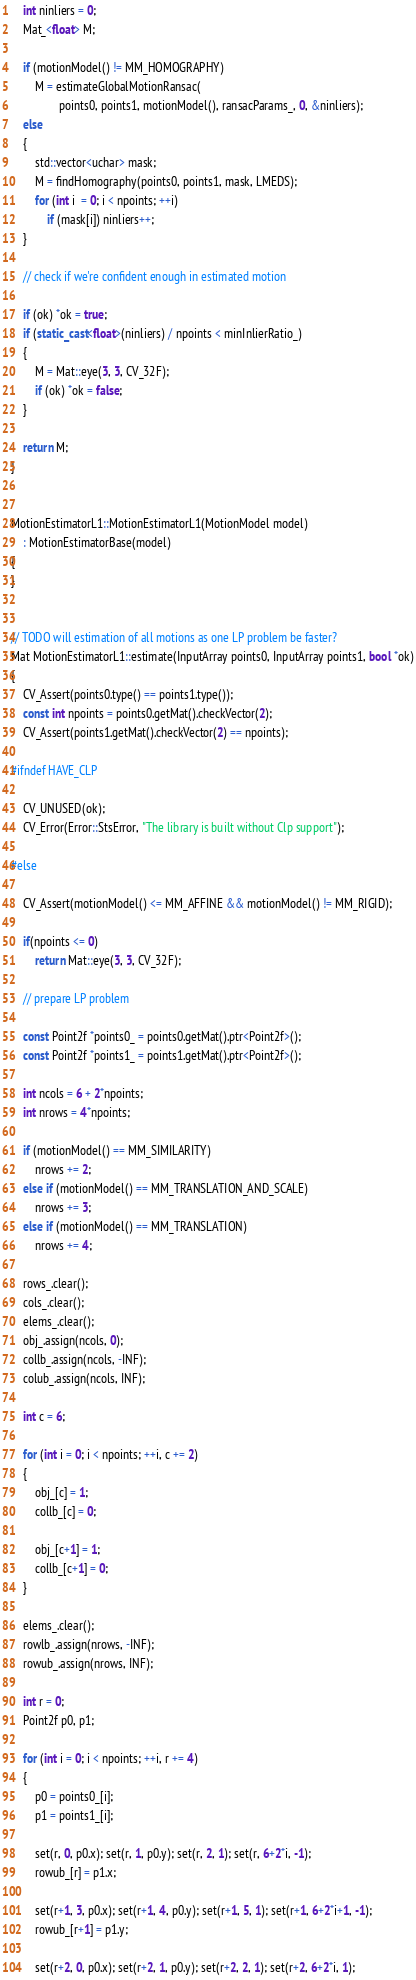Convert code to text. <code><loc_0><loc_0><loc_500><loc_500><_C++_>
    int ninliers = 0;
    Mat_<float> M;

    if (motionModel() != MM_HOMOGRAPHY)
        M = estimateGlobalMotionRansac(
                points0, points1, motionModel(), ransacParams_, 0, &ninliers);
    else
    {
        std::vector<uchar> mask;
        M = findHomography(points0, points1, mask, LMEDS);
        for (int i  = 0; i < npoints; ++i)
            if (mask[i]) ninliers++;
    }

    // check if we're confident enough in estimated motion

    if (ok) *ok = true;
    if (static_cast<float>(ninliers) / npoints < minInlierRatio_)
    {
        M = Mat::eye(3, 3, CV_32F);
        if (ok) *ok = false;
    }

    return M;
}


MotionEstimatorL1::MotionEstimatorL1(MotionModel model)
    : MotionEstimatorBase(model)
{
}


// TODO will estimation of all motions as one LP problem be faster?
Mat MotionEstimatorL1::estimate(InputArray points0, InputArray points1, bool *ok)
{
    CV_Assert(points0.type() == points1.type());
    const int npoints = points0.getMat().checkVector(2);
    CV_Assert(points1.getMat().checkVector(2) == npoints);

#ifndef HAVE_CLP

    CV_UNUSED(ok);
    CV_Error(Error::StsError, "The library is built without Clp support");

#else

    CV_Assert(motionModel() <= MM_AFFINE && motionModel() != MM_RIGID);

    if(npoints <= 0)
        return Mat::eye(3, 3, CV_32F);

    // prepare LP problem

    const Point2f *points0_ = points0.getMat().ptr<Point2f>();
    const Point2f *points1_ = points1.getMat().ptr<Point2f>();

    int ncols = 6 + 2*npoints;
    int nrows = 4*npoints;

    if (motionModel() == MM_SIMILARITY)
        nrows += 2;
    else if (motionModel() == MM_TRANSLATION_AND_SCALE)
        nrows += 3;
    else if (motionModel() == MM_TRANSLATION)
        nrows += 4;

    rows_.clear();
    cols_.clear();
    elems_.clear();
    obj_.assign(ncols, 0);
    collb_.assign(ncols, -INF);
    colub_.assign(ncols, INF);

    int c = 6;

    for (int i = 0; i < npoints; ++i, c += 2)
    {
        obj_[c] = 1;
        collb_[c] = 0;

        obj_[c+1] = 1;
        collb_[c+1] = 0;
    }

    elems_.clear();
    rowlb_.assign(nrows, -INF);
    rowub_.assign(nrows, INF);

    int r = 0;
    Point2f p0, p1;

    for (int i = 0; i < npoints; ++i, r += 4)
    {
        p0 = points0_[i];
        p1 = points1_[i];

        set(r, 0, p0.x); set(r, 1, p0.y); set(r, 2, 1); set(r, 6+2*i, -1);
        rowub_[r] = p1.x;

        set(r+1, 3, p0.x); set(r+1, 4, p0.y); set(r+1, 5, 1); set(r+1, 6+2*i+1, -1);
        rowub_[r+1] = p1.y;

        set(r+2, 0, p0.x); set(r+2, 1, p0.y); set(r+2, 2, 1); set(r+2, 6+2*i, 1);</code> 